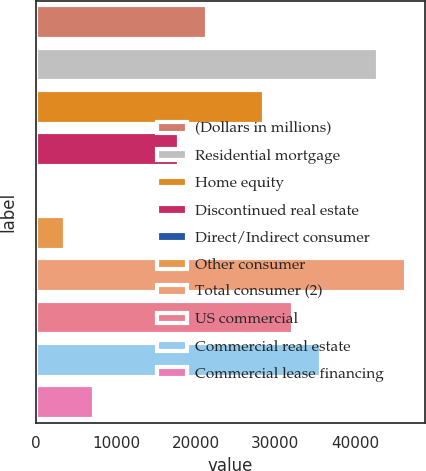Convert chart. <chart><loc_0><loc_0><loc_500><loc_500><bar_chart><fcel>(Dollars in millions)<fcel>Residential mortgage<fcel>Home equity<fcel>Discontinued real estate<fcel>Direct/Indirect consumer<fcel>Other consumer<fcel>Total consumer (2)<fcel>US commercial<fcel>Commercial real estate<fcel>Commercial lease financing<nl><fcel>21482.6<fcel>42879.2<fcel>28614.8<fcel>17916.5<fcel>86<fcel>3652.1<fcel>46445.3<fcel>32180.9<fcel>35747<fcel>7218.2<nl></chart> 